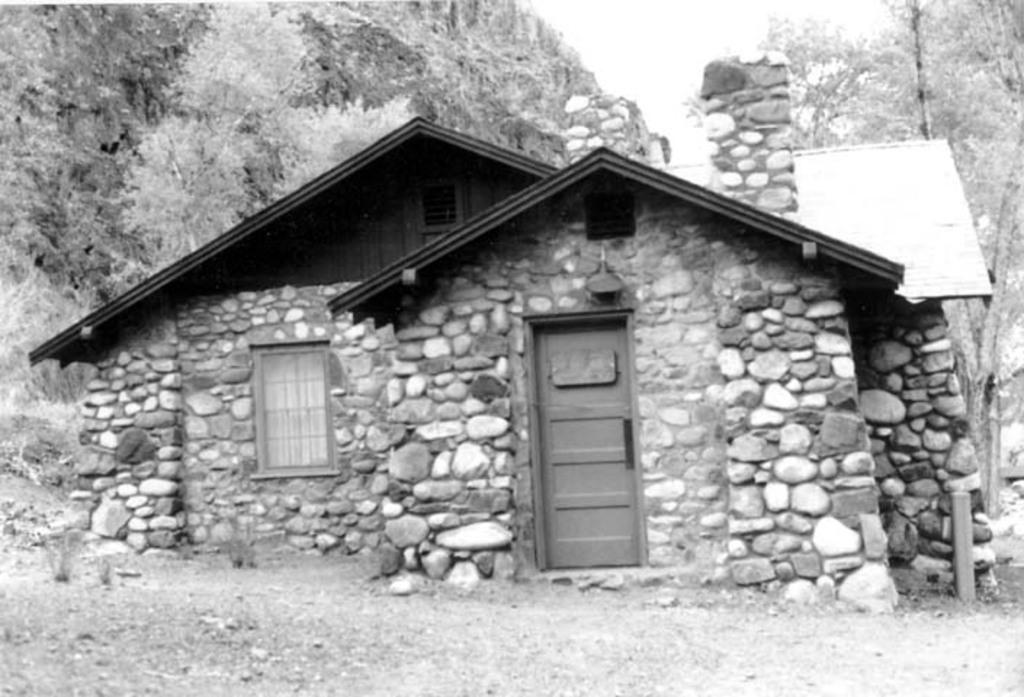What is the color scheme of the image? The image is black and white. What is the main subject in the middle of the image? There is a house in the middle of the image. What can be seen in the background of the image? There are many trees in the background of the image. What type of protest is taking place in front of the house in the image? There is no protest present in the image; it is a black and white image of a house with many trees in the background. How many nails can be seen holding the house together in the image? The image is in black and white, and there is no indication of nails or any construction details visible. 